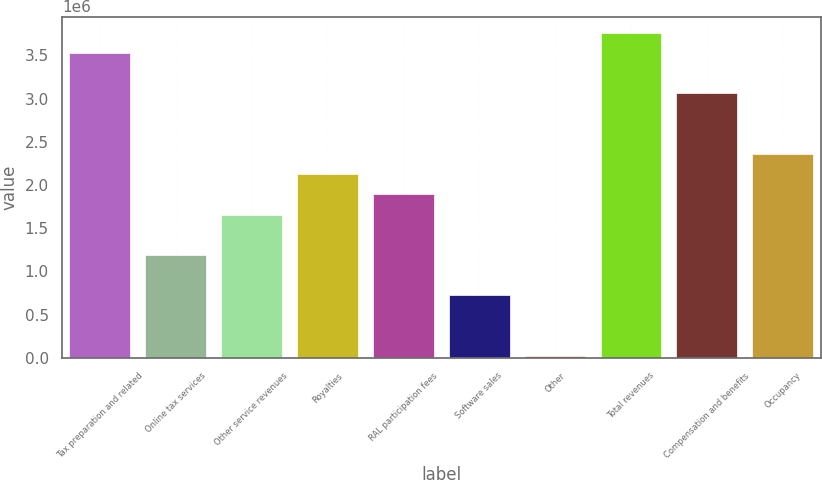Convert chart. <chart><loc_0><loc_0><loc_500><loc_500><bar_chart><fcel>Tax preparation and related<fcel>Online tax services<fcel>Other service revenues<fcel>Royalties<fcel>RAL participation fees<fcel>Software sales<fcel>Other<fcel>Total revenues<fcel>Compensation and benefits<fcel>Occupancy<nl><fcel>3.52668e+06<fcel>1.1899e+06<fcel>1.65726e+06<fcel>2.12461e+06<fcel>1.89094e+06<fcel>722544<fcel>21509<fcel>3.76036e+06<fcel>3.05933e+06<fcel>2.35829e+06<nl></chart> 